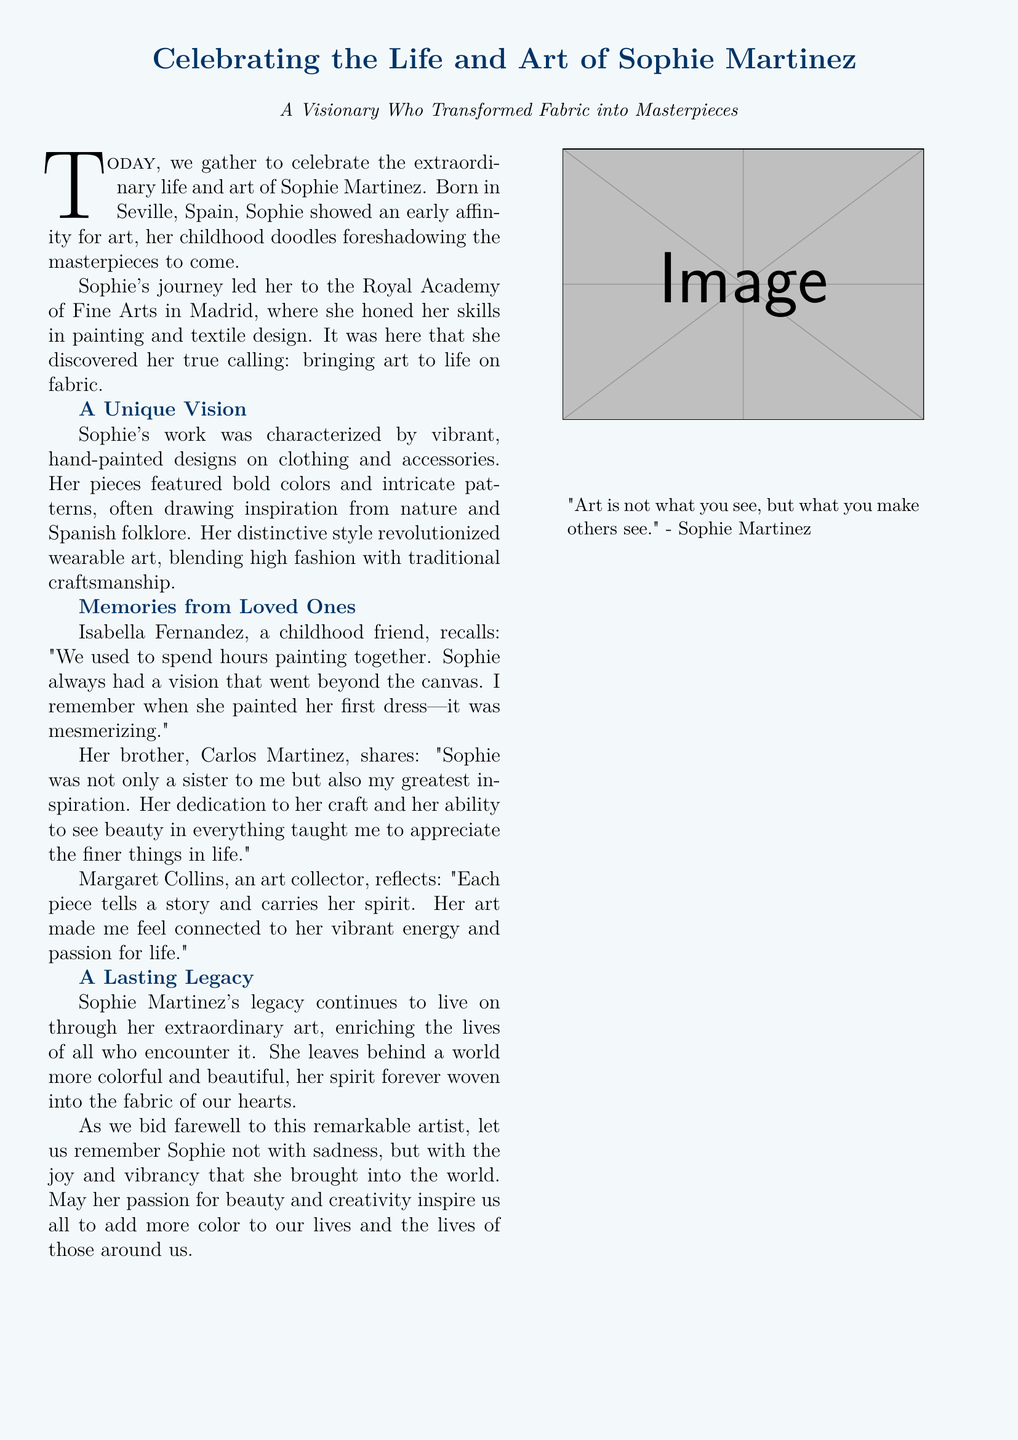What is the name of the artist being celebrated? The name of the artist is mentioned prominently at the beginning of the document and is Sophie Martinez.
Answer: Sophie Martinez Where was Sophie Martinez born? The place of birth is specified in the document, which is Seville, Spain.
Answer: Seville, Spain What educational institution did Sophie attend? The document states the name of the institution where Sophie honed her skills, which is the Royal Academy of Fine Arts in Madrid.
Answer: Royal Academy of Fine Arts in Madrid Who reminisced about painting with Sophie? A childhood friend of Sophie mentioned in the document recalls painting with her, and that person's name is Isabella Fernandez.
Answer: Isabella Fernandez What is a unique aspect of Sophie’s work? The document describes a distinct characteristic of Sophie's work focusing on the design and painting methods used in her creations.
Answer: Vibrant, hand-painted designs How did Isabel Fernandez describe Sophie's first dress? An anecdote in the document recounts the impression made by Sophie's first dress, highlighting how it affected her friend.
Answer: Mesmerizing What is the general sentiment of Margaret Collins towards Sophie’s art? The document includes a reflection from an art collector that conveys a specific emotion or connection felt when engaging with Sophie's work.
Answer: Connected to her vibrant energy What did Sophie say about art? The document includes a quote attributed to Sophie, summarizing her perspective on art itself, which is vital in a eulogy context.
Answer: "Art is not what you see, but what you make others see." In what way is Sophie’s legacy described? The document articulates how the legacy of Sophie Martinez is perceived by those who appreciate her work, hinting at a broader impact on the community.
Answer: A world more colorful and beautiful 